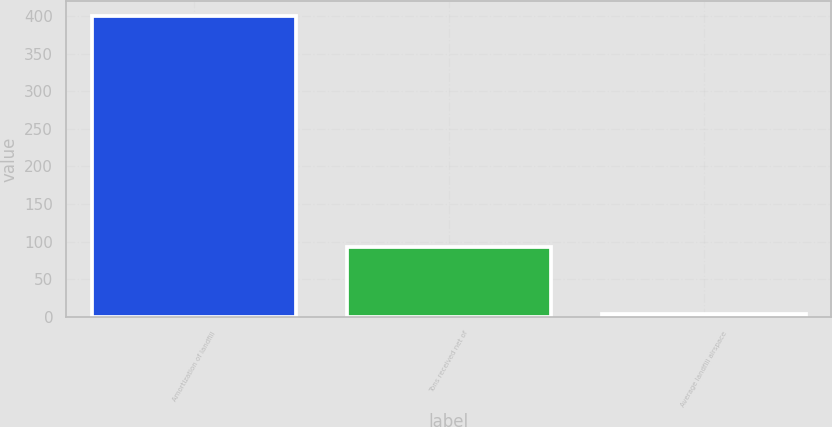Convert chart to OTSL. <chart><loc_0><loc_0><loc_500><loc_500><bar_chart><fcel>Amortization of landfill<fcel>Tons received net of<fcel>Average landfill airspace<nl><fcel>400<fcel>93<fcel>4.29<nl></chart> 